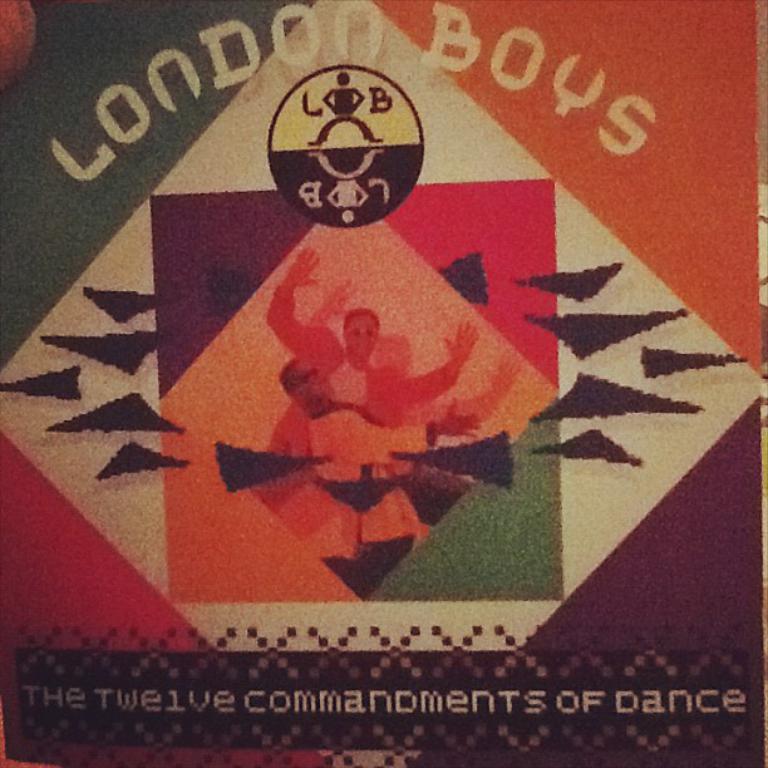How many commandments of dance are their?
Your answer should be compact. Twelve. What group put out this album?
Provide a short and direct response. London boys. 